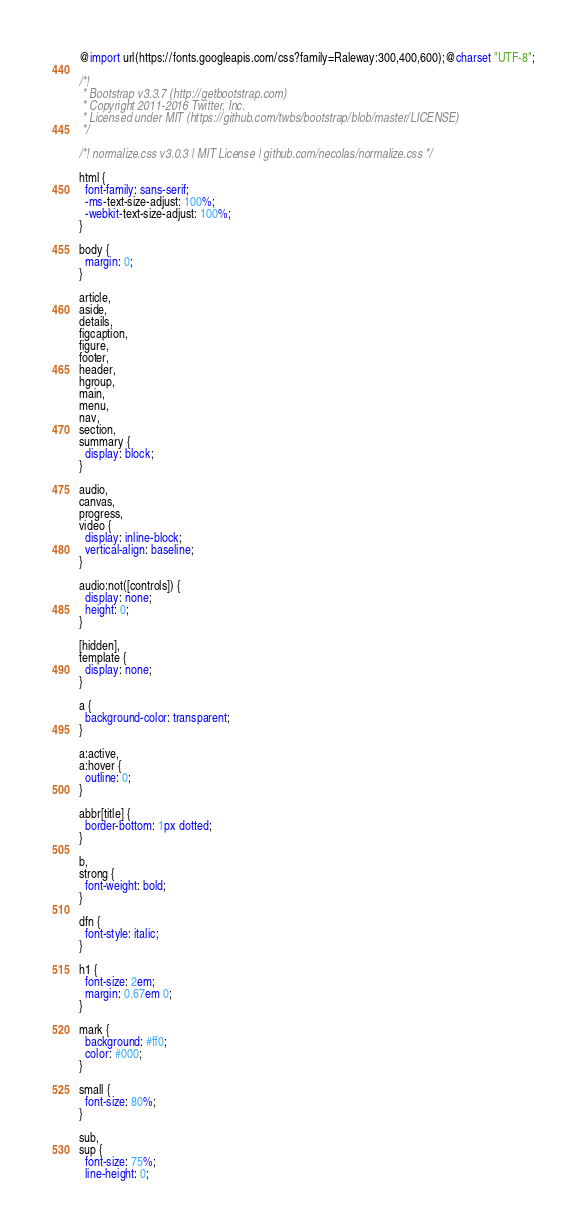Convert code to text. <code><loc_0><loc_0><loc_500><loc_500><_CSS_>@import url(https://fonts.googleapis.com/css?family=Raleway:300,400,600);@charset "UTF-8";

/*!
 * Bootstrap v3.3.7 (http://getbootstrap.com)
 * Copyright 2011-2016 Twitter, Inc.
 * Licensed under MIT (https://github.com/twbs/bootstrap/blob/master/LICENSE)
 */

/*! normalize.css v3.0.3 | MIT License | github.com/necolas/normalize.css */

html {
  font-family: sans-serif;
  -ms-text-size-adjust: 100%;
  -webkit-text-size-adjust: 100%;
}

body {
  margin: 0;
}

article,
aside,
details,
figcaption,
figure,
footer,
header,
hgroup,
main,
menu,
nav,
section,
summary {
  display: block;
}

audio,
canvas,
progress,
video {
  display: inline-block;
  vertical-align: baseline;
}

audio:not([controls]) {
  display: none;
  height: 0;
}

[hidden],
template {
  display: none;
}

a {
  background-color: transparent;
}

a:active,
a:hover {
  outline: 0;
}

abbr[title] {
  border-bottom: 1px dotted;
}

b,
strong {
  font-weight: bold;
}

dfn {
  font-style: italic;
}

h1 {
  font-size: 2em;
  margin: 0.67em 0;
}

mark {
  background: #ff0;
  color: #000;
}

small {
  font-size: 80%;
}

sub,
sup {
  font-size: 75%;
  line-height: 0;</code> 